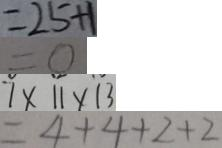Convert formula to latex. <formula><loc_0><loc_0><loc_500><loc_500>= 2 5 + 1 
 = 0 
 7 \times 1 1 \times 1 3 
 = 4 + 4 + 2 + 2</formula> 